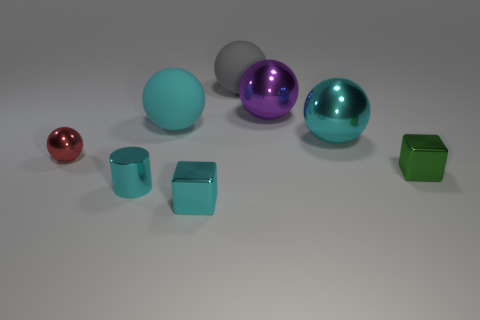Subtract all small red spheres. How many spheres are left? 4 Subtract all red spheres. How many spheres are left? 4 Subtract 1 cubes. How many cubes are left? 1 Add 1 gray rubber spheres. How many gray rubber spheres exist? 2 Add 1 big yellow objects. How many objects exist? 9 Subtract 1 gray spheres. How many objects are left? 7 Subtract all balls. How many objects are left? 3 Subtract all yellow cylinders. Subtract all gray spheres. How many cylinders are left? 1 Subtract all green blocks. How many red balls are left? 1 Subtract all large purple matte objects. Subtract all tiny balls. How many objects are left? 7 